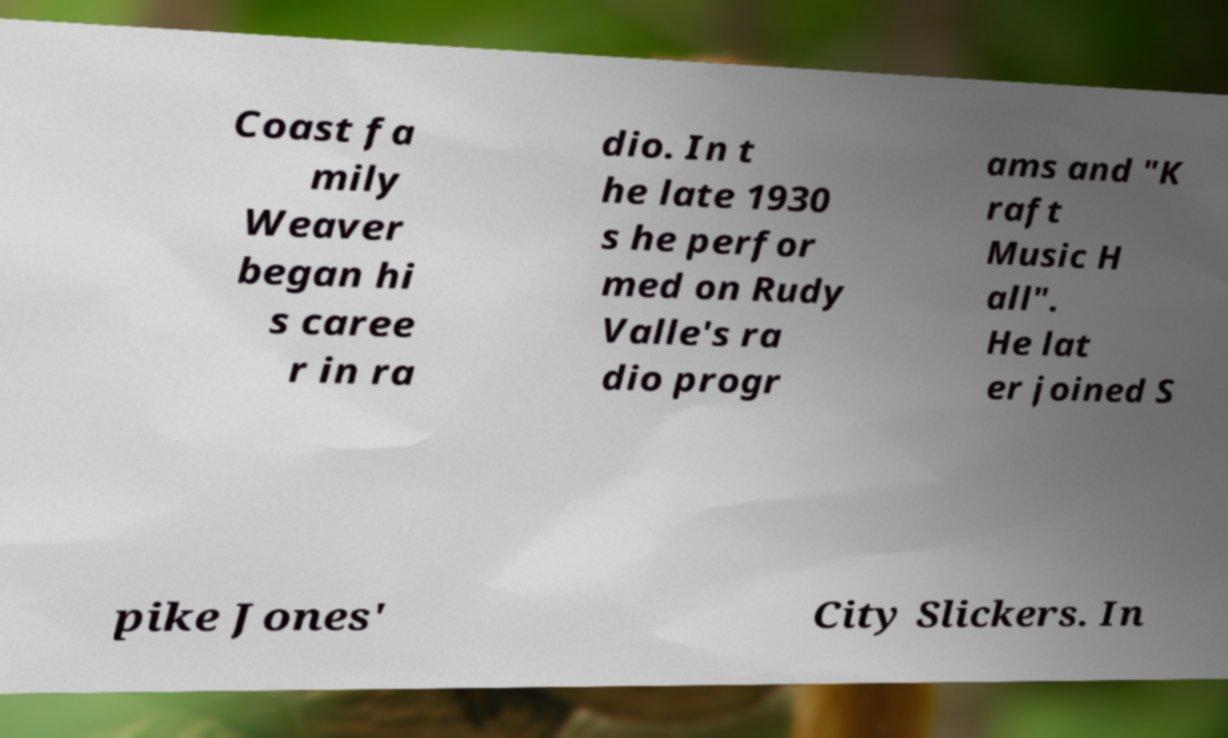What messages or text are displayed in this image? I need them in a readable, typed format. Coast fa mily Weaver began hi s caree r in ra dio. In t he late 1930 s he perfor med on Rudy Valle's ra dio progr ams and "K raft Music H all". He lat er joined S pike Jones' City Slickers. In 